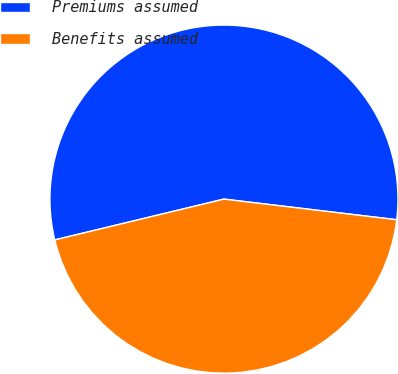<chart> <loc_0><loc_0><loc_500><loc_500><pie_chart><fcel>Premiums assumed<fcel>Benefits assumed<nl><fcel>55.66%<fcel>44.34%<nl></chart> 